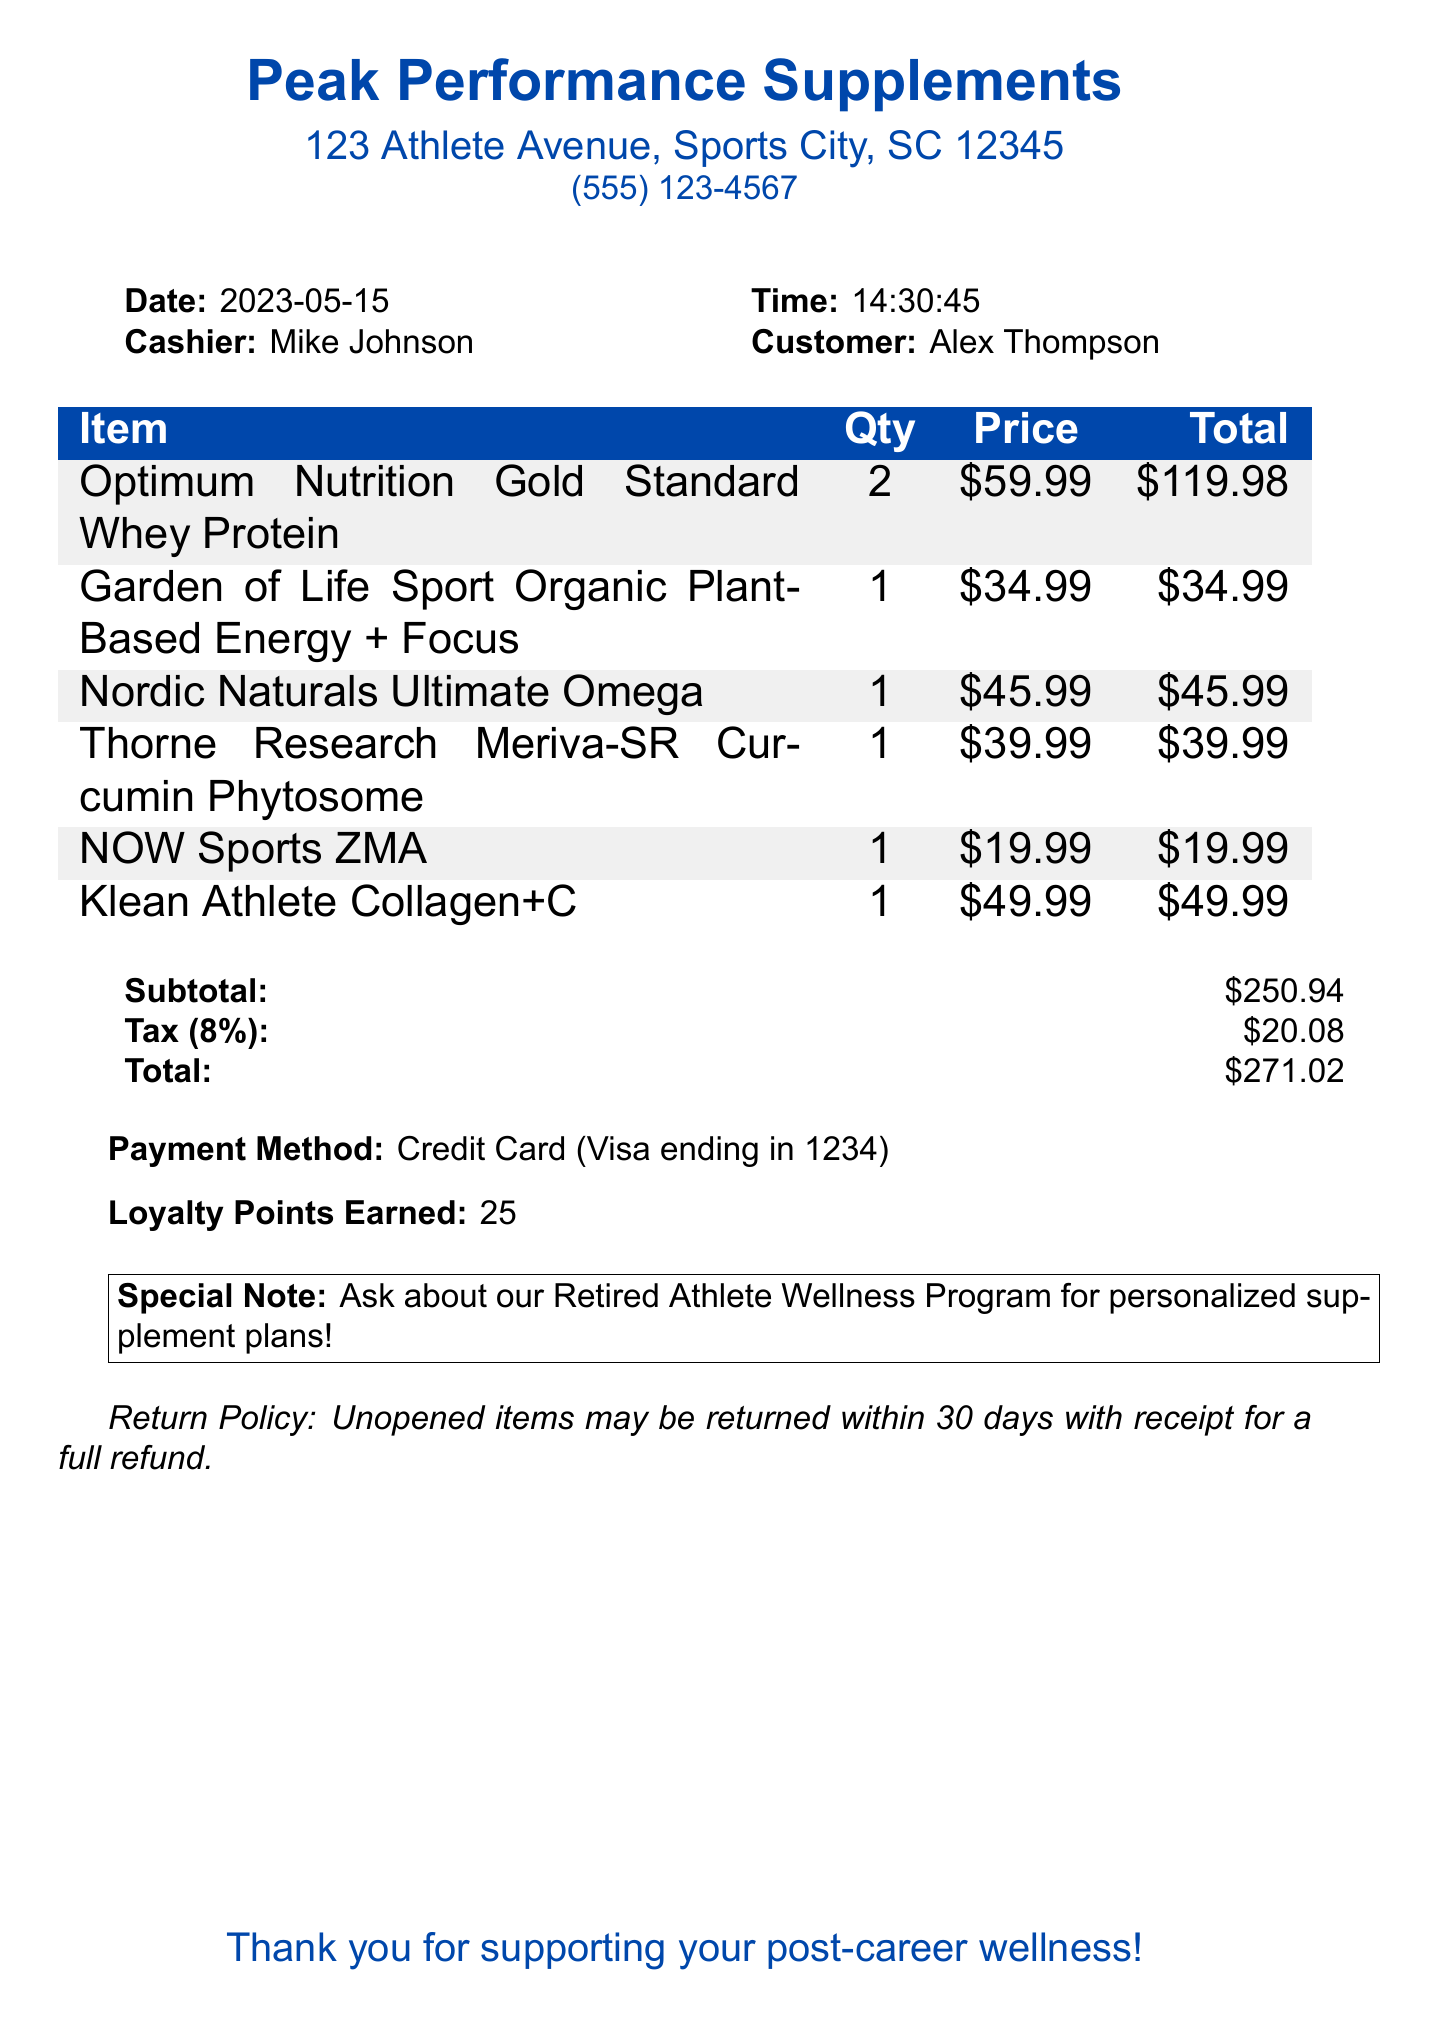What is the store name? The store name is located at the beginning of the document under the header section.
Answer: Peak Performance Supplements What is the date of the transaction? The date is listed alongside the cashier's name and customer information in the document.
Answer: 2023-05-15 Who is the cashier? The cashier's name is mentioned right next to the date and time of the transaction.
Answer: Mike Johnson What is the total amount spent? The total amount is listed in the summary section at the bottom of the document.
Answer: $271.02 How many loyalty points were earned? The loyalty points earned are detailed in a specific section of the document.
Answer: 25 What type of payment was used? The payment method is specifically stated in the document.
Answer: Credit Card What is the purpose of the "NOW Sports ZMA"? The description of the item outlines its purpose within the context of the purchase.
Answer: Sleep and recovery aid for busy commentators How many items were purchased in total? The number of items can be counted from the list in the receipt.
Answer: 6 What is the return policy for items? The return policy is mentioned at the end of the document and outlines the terms clearly.
Answer: Unopened items may be returned within 30 days with receipt for a full refund Is there a special program mentioned in the receipt? The special note section of the document indicates a specific program for retired athletes.
Answer: Retired Athlete Wellness Program 